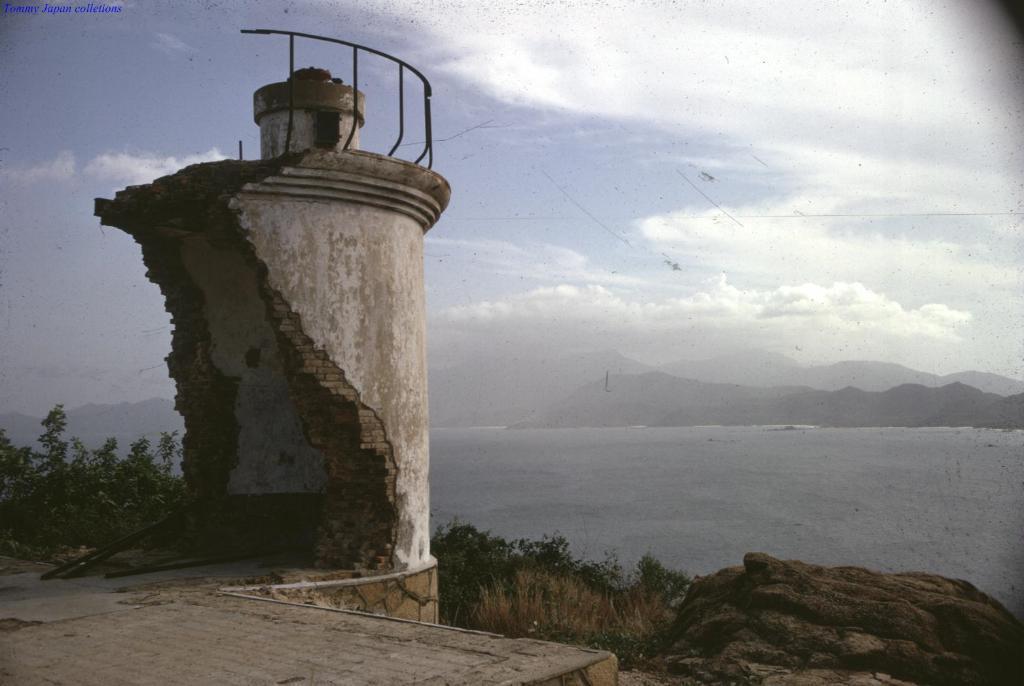Can you describe this image briefly? Here on the left side we can see a tower, which is broken into half present over there and we can see plants present all over there and we can see rock stones present and in the front we can see water present all over there and we can see mountains in the far present and we can see clouds in sky. 